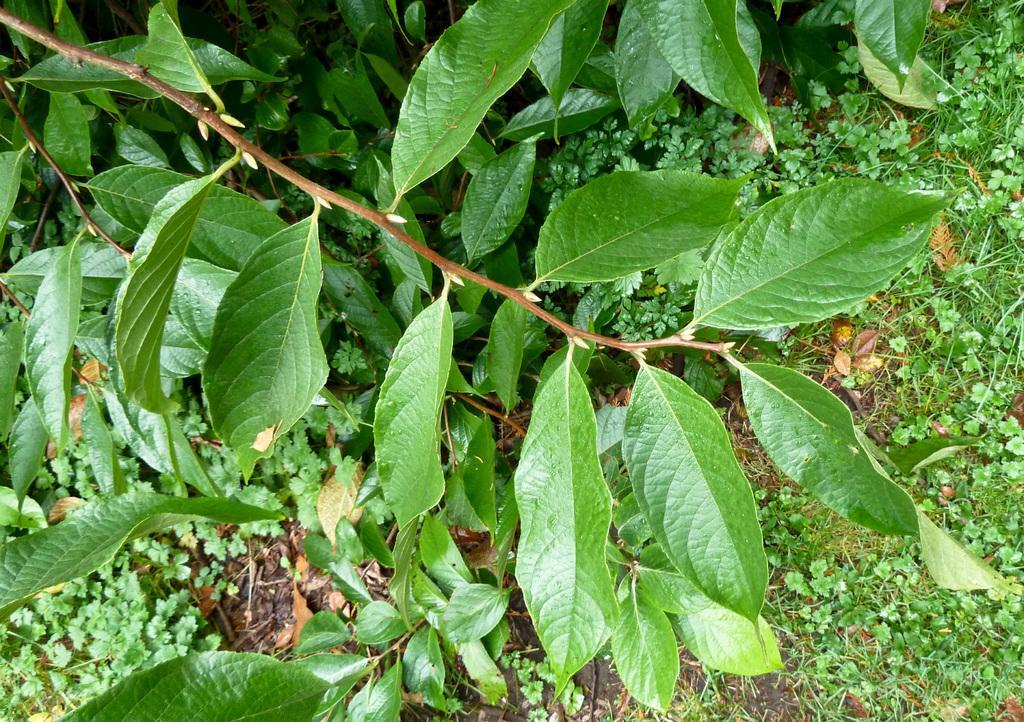In one or two sentences, can you explain what this image depicts? In the picture we can see some plants under it we can see plant saplings and grass on the path. 